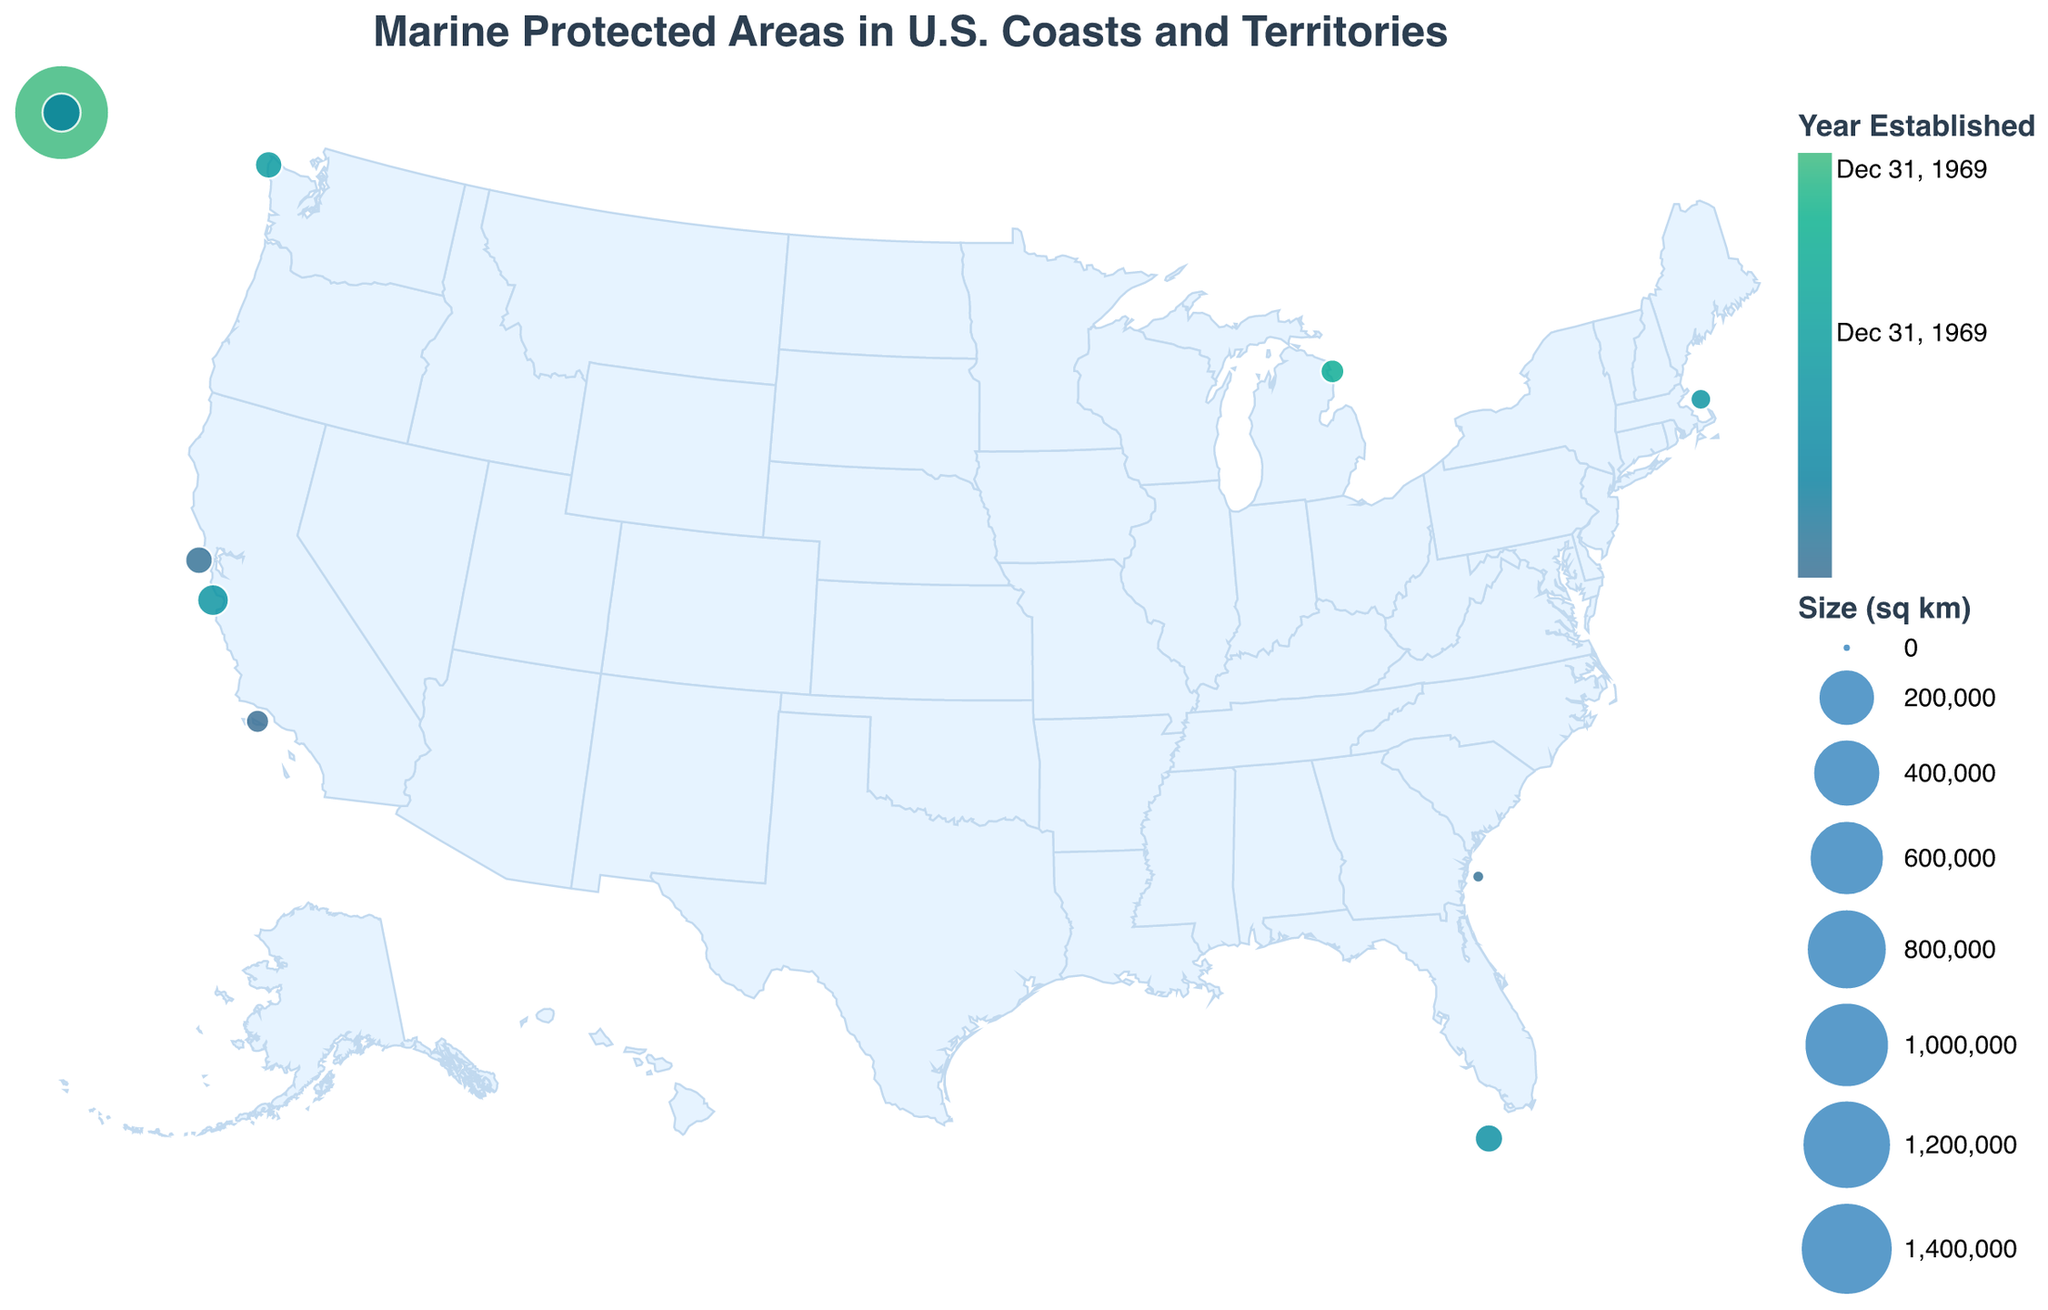What is the total size in square kilometers of all Marine Protected Areas combined? Add up the size of all Marine Protected Areas: 3800 (Channel Islands) + 9600 (Florida Keys) + 15783 (Monterey Bay) + 1508870 (Papahānaumokuākea) + 8259 (Olympic Coast) + 2181 (Stellwagen Bank) + 4300 (Thunder Bay) + 8534 (Greater Farallones) + 35295 (American Samoa) + 57 (Gray's Reef) = 1552679
Answer: 1552679 Which Marine Protected Area has the largest size? Look at the size of each Marine Protected Area and identify the largest one. The Papahānaumokuākea Marine National Monument has 1508870 square kilometers, which is the largest.
Answer: Papahānaumokuākea Marine National Monument Which Marine Protected Area was established first? Check the 'Year Established' for each Marine Protected Area and find the earliest year. The Channel Islands National Marine Sanctuary was established in 1980.
Answer: Channel Islands National Marine Sanctuary How many Marine Protected Areas were established in the 1990s? Look at the 'Year Established' for each area and count those established between 1990 and 1999. The areas are Florida Keys (1990), Monterey Bay (1992), Stellwagen Bank (1992), and Olympic Coast (1994).
Answer: 4 Compare the sizes of the Channel Islands National Marine Sanctuary and Florida Keys National Marine Sanctuary. Which one is larger? Look at the size of both areas. The Channel Islands has 3800 square kilometers and the Florida Keys has 9600 square kilometers. The Florida Keys is larger.
Answer: Florida Keys National Marine Sanctuary What is the average size of the Marine Protected Areas? Add up the sizes of all the Marine Protected Areas and divide by the number of areas: (3800 + 9600 + 15783 + 1508870 + 8259 + 2181 + 4300 + 8534 + 35295 + 57) / 10 = 155267.9
Answer: 155267.9 Which Marine Protected Area near the Pacific Ocean has the smallest size? Check the Marine Protected Areas near the Pacific Ocean (Channel Islands, Monterey Bay, Papahānaumokuākea, Olympic Coast) and compare their sizes. The Channel Islands has the smallest size of 3800 square kilometers.
Answer: Channel Islands National Marine Sanctuary What is the spread of the establishment years of the Marine Protected Areas? Identify the earliest and latest years: 1980 (Channel Islands) and 2006 (Papahānaumokuākea). So, the spread is from 1980 to 2006.
Answer: 1980 to 2006 How does the size of Thunder Bay National Marine Sanctuary compare to Gray's Reef National Marine Sanctuary? Look at the size of both areas. Thunder Bay has 4300 square kilometers and Gray's Reef has 57 square kilometers. Thus, Thunder Bay is significantly larger.
Answer: Thunder Bay National Marine Sanctuary 